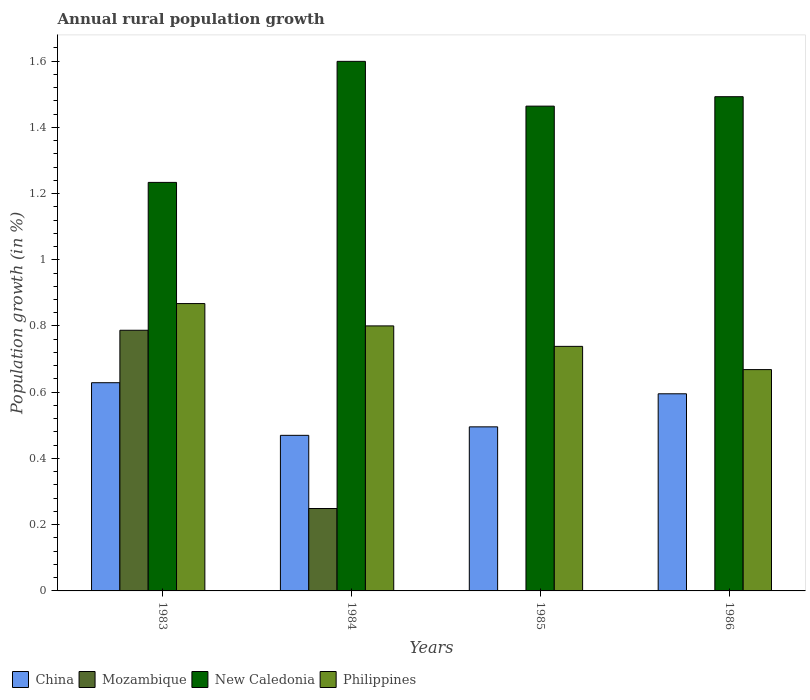How many different coloured bars are there?
Keep it short and to the point. 4. How many bars are there on the 4th tick from the right?
Ensure brevity in your answer.  4. What is the label of the 2nd group of bars from the left?
Your answer should be compact. 1984. What is the percentage of rural population growth in China in 1984?
Make the answer very short. 0.47. Across all years, what is the maximum percentage of rural population growth in China?
Offer a very short reply. 0.63. Across all years, what is the minimum percentage of rural population growth in Philippines?
Offer a terse response. 0.67. What is the total percentage of rural population growth in China in the graph?
Keep it short and to the point. 2.19. What is the difference between the percentage of rural population growth in New Caledonia in 1983 and that in 1984?
Make the answer very short. -0.37. What is the difference between the percentage of rural population growth in Philippines in 1986 and the percentage of rural population growth in China in 1985?
Ensure brevity in your answer.  0.17. What is the average percentage of rural population growth in Mozambique per year?
Make the answer very short. 0.26. In the year 1984, what is the difference between the percentage of rural population growth in China and percentage of rural population growth in Mozambique?
Your answer should be compact. 0.22. In how many years, is the percentage of rural population growth in Philippines greater than 0.9600000000000001 %?
Offer a very short reply. 0. What is the ratio of the percentage of rural population growth in Philippines in 1984 to that in 1985?
Your answer should be compact. 1.08. Is the difference between the percentage of rural population growth in China in 1983 and 1984 greater than the difference between the percentage of rural population growth in Mozambique in 1983 and 1984?
Make the answer very short. No. What is the difference between the highest and the second highest percentage of rural population growth in New Caledonia?
Offer a very short reply. 0.11. What is the difference between the highest and the lowest percentage of rural population growth in Philippines?
Your response must be concise. 0.2. Is it the case that in every year, the sum of the percentage of rural population growth in New Caledonia and percentage of rural population growth in Mozambique is greater than the percentage of rural population growth in Philippines?
Offer a very short reply. Yes. Are all the bars in the graph horizontal?
Keep it short and to the point. No. Are the values on the major ticks of Y-axis written in scientific E-notation?
Your response must be concise. No. Does the graph contain grids?
Ensure brevity in your answer.  No. How many legend labels are there?
Provide a succinct answer. 4. How are the legend labels stacked?
Your answer should be very brief. Horizontal. What is the title of the graph?
Your answer should be compact. Annual rural population growth. Does "Botswana" appear as one of the legend labels in the graph?
Offer a terse response. No. What is the label or title of the Y-axis?
Your answer should be compact. Population growth (in %). What is the Population growth (in %) in China in 1983?
Offer a terse response. 0.63. What is the Population growth (in %) of Mozambique in 1983?
Ensure brevity in your answer.  0.79. What is the Population growth (in %) in New Caledonia in 1983?
Ensure brevity in your answer.  1.23. What is the Population growth (in %) in Philippines in 1983?
Offer a very short reply. 0.87. What is the Population growth (in %) in China in 1984?
Offer a very short reply. 0.47. What is the Population growth (in %) in Mozambique in 1984?
Provide a succinct answer. 0.25. What is the Population growth (in %) of New Caledonia in 1984?
Provide a short and direct response. 1.6. What is the Population growth (in %) in Philippines in 1984?
Keep it short and to the point. 0.8. What is the Population growth (in %) in China in 1985?
Offer a terse response. 0.5. What is the Population growth (in %) of Mozambique in 1985?
Make the answer very short. 0. What is the Population growth (in %) in New Caledonia in 1985?
Keep it short and to the point. 1.46. What is the Population growth (in %) of Philippines in 1985?
Offer a very short reply. 0.74. What is the Population growth (in %) of China in 1986?
Your answer should be very brief. 0.6. What is the Population growth (in %) of Mozambique in 1986?
Your answer should be very brief. 0. What is the Population growth (in %) of New Caledonia in 1986?
Offer a terse response. 1.49. What is the Population growth (in %) of Philippines in 1986?
Your answer should be compact. 0.67. Across all years, what is the maximum Population growth (in %) of China?
Give a very brief answer. 0.63. Across all years, what is the maximum Population growth (in %) in Mozambique?
Offer a terse response. 0.79. Across all years, what is the maximum Population growth (in %) of New Caledonia?
Provide a short and direct response. 1.6. Across all years, what is the maximum Population growth (in %) of Philippines?
Offer a very short reply. 0.87. Across all years, what is the minimum Population growth (in %) in China?
Give a very brief answer. 0.47. Across all years, what is the minimum Population growth (in %) in New Caledonia?
Keep it short and to the point. 1.23. Across all years, what is the minimum Population growth (in %) of Philippines?
Offer a terse response. 0.67. What is the total Population growth (in %) of China in the graph?
Make the answer very short. 2.19. What is the total Population growth (in %) in Mozambique in the graph?
Keep it short and to the point. 1.04. What is the total Population growth (in %) in New Caledonia in the graph?
Provide a succinct answer. 5.79. What is the total Population growth (in %) in Philippines in the graph?
Give a very brief answer. 3.07. What is the difference between the Population growth (in %) of China in 1983 and that in 1984?
Provide a short and direct response. 0.16. What is the difference between the Population growth (in %) of Mozambique in 1983 and that in 1984?
Your response must be concise. 0.54. What is the difference between the Population growth (in %) of New Caledonia in 1983 and that in 1984?
Provide a short and direct response. -0.37. What is the difference between the Population growth (in %) in Philippines in 1983 and that in 1984?
Offer a terse response. 0.07. What is the difference between the Population growth (in %) of China in 1983 and that in 1985?
Provide a succinct answer. 0.13. What is the difference between the Population growth (in %) in New Caledonia in 1983 and that in 1985?
Provide a succinct answer. -0.23. What is the difference between the Population growth (in %) in Philippines in 1983 and that in 1985?
Offer a terse response. 0.13. What is the difference between the Population growth (in %) of China in 1983 and that in 1986?
Make the answer very short. 0.03. What is the difference between the Population growth (in %) of New Caledonia in 1983 and that in 1986?
Offer a terse response. -0.26. What is the difference between the Population growth (in %) of Philippines in 1983 and that in 1986?
Make the answer very short. 0.2. What is the difference between the Population growth (in %) in China in 1984 and that in 1985?
Your response must be concise. -0.03. What is the difference between the Population growth (in %) in New Caledonia in 1984 and that in 1985?
Offer a very short reply. 0.14. What is the difference between the Population growth (in %) of Philippines in 1984 and that in 1985?
Your answer should be compact. 0.06. What is the difference between the Population growth (in %) in China in 1984 and that in 1986?
Your answer should be very brief. -0.13. What is the difference between the Population growth (in %) in New Caledonia in 1984 and that in 1986?
Provide a short and direct response. 0.11. What is the difference between the Population growth (in %) in Philippines in 1984 and that in 1986?
Your answer should be compact. 0.13. What is the difference between the Population growth (in %) of China in 1985 and that in 1986?
Ensure brevity in your answer.  -0.1. What is the difference between the Population growth (in %) in New Caledonia in 1985 and that in 1986?
Your answer should be compact. -0.03. What is the difference between the Population growth (in %) in Philippines in 1985 and that in 1986?
Provide a short and direct response. 0.07. What is the difference between the Population growth (in %) of China in 1983 and the Population growth (in %) of Mozambique in 1984?
Your answer should be very brief. 0.38. What is the difference between the Population growth (in %) in China in 1983 and the Population growth (in %) in New Caledonia in 1984?
Offer a terse response. -0.97. What is the difference between the Population growth (in %) in China in 1983 and the Population growth (in %) in Philippines in 1984?
Provide a short and direct response. -0.17. What is the difference between the Population growth (in %) of Mozambique in 1983 and the Population growth (in %) of New Caledonia in 1984?
Offer a very short reply. -0.81. What is the difference between the Population growth (in %) in Mozambique in 1983 and the Population growth (in %) in Philippines in 1984?
Ensure brevity in your answer.  -0.01. What is the difference between the Population growth (in %) of New Caledonia in 1983 and the Population growth (in %) of Philippines in 1984?
Your answer should be very brief. 0.43. What is the difference between the Population growth (in %) in China in 1983 and the Population growth (in %) in New Caledonia in 1985?
Offer a terse response. -0.84. What is the difference between the Population growth (in %) of China in 1983 and the Population growth (in %) of Philippines in 1985?
Ensure brevity in your answer.  -0.11. What is the difference between the Population growth (in %) in Mozambique in 1983 and the Population growth (in %) in New Caledonia in 1985?
Keep it short and to the point. -0.68. What is the difference between the Population growth (in %) in Mozambique in 1983 and the Population growth (in %) in Philippines in 1985?
Make the answer very short. 0.05. What is the difference between the Population growth (in %) of New Caledonia in 1983 and the Population growth (in %) of Philippines in 1985?
Ensure brevity in your answer.  0.5. What is the difference between the Population growth (in %) of China in 1983 and the Population growth (in %) of New Caledonia in 1986?
Ensure brevity in your answer.  -0.86. What is the difference between the Population growth (in %) in China in 1983 and the Population growth (in %) in Philippines in 1986?
Offer a terse response. -0.04. What is the difference between the Population growth (in %) in Mozambique in 1983 and the Population growth (in %) in New Caledonia in 1986?
Offer a very short reply. -0.71. What is the difference between the Population growth (in %) of Mozambique in 1983 and the Population growth (in %) of Philippines in 1986?
Offer a very short reply. 0.12. What is the difference between the Population growth (in %) of New Caledonia in 1983 and the Population growth (in %) of Philippines in 1986?
Your answer should be very brief. 0.57. What is the difference between the Population growth (in %) in China in 1984 and the Population growth (in %) in New Caledonia in 1985?
Ensure brevity in your answer.  -0.99. What is the difference between the Population growth (in %) of China in 1984 and the Population growth (in %) of Philippines in 1985?
Keep it short and to the point. -0.27. What is the difference between the Population growth (in %) in Mozambique in 1984 and the Population growth (in %) in New Caledonia in 1985?
Offer a terse response. -1.22. What is the difference between the Population growth (in %) of Mozambique in 1984 and the Population growth (in %) of Philippines in 1985?
Your answer should be very brief. -0.49. What is the difference between the Population growth (in %) of New Caledonia in 1984 and the Population growth (in %) of Philippines in 1985?
Ensure brevity in your answer.  0.86. What is the difference between the Population growth (in %) in China in 1984 and the Population growth (in %) in New Caledonia in 1986?
Offer a very short reply. -1.02. What is the difference between the Population growth (in %) of China in 1984 and the Population growth (in %) of Philippines in 1986?
Ensure brevity in your answer.  -0.2. What is the difference between the Population growth (in %) of Mozambique in 1984 and the Population growth (in %) of New Caledonia in 1986?
Make the answer very short. -1.24. What is the difference between the Population growth (in %) in Mozambique in 1984 and the Population growth (in %) in Philippines in 1986?
Keep it short and to the point. -0.42. What is the difference between the Population growth (in %) in New Caledonia in 1984 and the Population growth (in %) in Philippines in 1986?
Your answer should be compact. 0.93. What is the difference between the Population growth (in %) in China in 1985 and the Population growth (in %) in New Caledonia in 1986?
Ensure brevity in your answer.  -1. What is the difference between the Population growth (in %) of China in 1985 and the Population growth (in %) of Philippines in 1986?
Your answer should be very brief. -0.17. What is the difference between the Population growth (in %) of New Caledonia in 1985 and the Population growth (in %) of Philippines in 1986?
Your answer should be very brief. 0.8. What is the average Population growth (in %) in China per year?
Give a very brief answer. 0.55. What is the average Population growth (in %) in Mozambique per year?
Your response must be concise. 0.26. What is the average Population growth (in %) of New Caledonia per year?
Ensure brevity in your answer.  1.45. What is the average Population growth (in %) of Philippines per year?
Offer a terse response. 0.77. In the year 1983, what is the difference between the Population growth (in %) of China and Population growth (in %) of Mozambique?
Your answer should be very brief. -0.16. In the year 1983, what is the difference between the Population growth (in %) of China and Population growth (in %) of New Caledonia?
Give a very brief answer. -0.6. In the year 1983, what is the difference between the Population growth (in %) in China and Population growth (in %) in Philippines?
Offer a terse response. -0.24. In the year 1983, what is the difference between the Population growth (in %) in Mozambique and Population growth (in %) in New Caledonia?
Ensure brevity in your answer.  -0.45. In the year 1983, what is the difference between the Population growth (in %) of Mozambique and Population growth (in %) of Philippines?
Your answer should be compact. -0.08. In the year 1983, what is the difference between the Population growth (in %) of New Caledonia and Population growth (in %) of Philippines?
Offer a terse response. 0.37. In the year 1984, what is the difference between the Population growth (in %) in China and Population growth (in %) in Mozambique?
Ensure brevity in your answer.  0.22. In the year 1984, what is the difference between the Population growth (in %) of China and Population growth (in %) of New Caledonia?
Provide a short and direct response. -1.13. In the year 1984, what is the difference between the Population growth (in %) in China and Population growth (in %) in Philippines?
Give a very brief answer. -0.33. In the year 1984, what is the difference between the Population growth (in %) in Mozambique and Population growth (in %) in New Caledonia?
Your response must be concise. -1.35. In the year 1984, what is the difference between the Population growth (in %) of Mozambique and Population growth (in %) of Philippines?
Your answer should be very brief. -0.55. In the year 1984, what is the difference between the Population growth (in %) of New Caledonia and Population growth (in %) of Philippines?
Ensure brevity in your answer.  0.8. In the year 1985, what is the difference between the Population growth (in %) of China and Population growth (in %) of New Caledonia?
Your response must be concise. -0.97. In the year 1985, what is the difference between the Population growth (in %) of China and Population growth (in %) of Philippines?
Give a very brief answer. -0.24. In the year 1985, what is the difference between the Population growth (in %) of New Caledonia and Population growth (in %) of Philippines?
Ensure brevity in your answer.  0.73. In the year 1986, what is the difference between the Population growth (in %) of China and Population growth (in %) of New Caledonia?
Your answer should be compact. -0.9. In the year 1986, what is the difference between the Population growth (in %) in China and Population growth (in %) in Philippines?
Keep it short and to the point. -0.07. In the year 1986, what is the difference between the Population growth (in %) of New Caledonia and Population growth (in %) of Philippines?
Your answer should be compact. 0.82. What is the ratio of the Population growth (in %) in China in 1983 to that in 1984?
Offer a terse response. 1.34. What is the ratio of the Population growth (in %) of Mozambique in 1983 to that in 1984?
Your answer should be very brief. 3.16. What is the ratio of the Population growth (in %) of New Caledonia in 1983 to that in 1984?
Offer a terse response. 0.77. What is the ratio of the Population growth (in %) of Philippines in 1983 to that in 1984?
Make the answer very short. 1.08. What is the ratio of the Population growth (in %) of China in 1983 to that in 1985?
Offer a very short reply. 1.27. What is the ratio of the Population growth (in %) in New Caledonia in 1983 to that in 1985?
Offer a terse response. 0.84. What is the ratio of the Population growth (in %) of Philippines in 1983 to that in 1985?
Provide a short and direct response. 1.18. What is the ratio of the Population growth (in %) in China in 1983 to that in 1986?
Offer a very short reply. 1.06. What is the ratio of the Population growth (in %) of New Caledonia in 1983 to that in 1986?
Offer a terse response. 0.83. What is the ratio of the Population growth (in %) of Philippines in 1983 to that in 1986?
Your answer should be very brief. 1.3. What is the ratio of the Population growth (in %) of China in 1984 to that in 1985?
Provide a short and direct response. 0.95. What is the ratio of the Population growth (in %) in New Caledonia in 1984 to that in 1985?
Offer a very short reply. 1.09. What is the ratio of the Population growth (in %) of Philippines in 1984 to that in 1985?
Your answer should be very brief. 1.08. What is the ratio of the Population growth (in %) of China in 1984 to that in 1986?
Give a very brief answer. 0.79. What is the ratio of the Population growth (in %) in New Caledonia in 1984 to that in 1986?
Your response must be concise. 1.07. What is the ratio of the Population growth (in %) in Philippines in 1984 to that in 1986?
Your response must be concise. 1.2. What is the ratio of the Population growth (in %) in China in 1985 to that in 1986?
Your answer should be very brief. 0.83. What is the ratio of the Population growth (in %) of New Caledonia in 1985 to that in 1986?
Your answer should be compact. 0.98. What is the ratio of the Population growth (in %) in Philippines in 1985 to that in 1986?
Your answer should be compact. 1.1. What is the difference between the highest and the second highest Population growth (in %) of China?
Provide a short and direct response. 0.03. What is the difference between the highest and the second highest Population growth (in %) of New Caledonia?
Keep it short and to the point. 0.11. What is the difference between the highest and the second highest Population growth (in %) of Philippines?
Make the answer very short. 0.07. What is the difference between the highest and the lowest Population growth (in %) of China?
Your response must be concise. 0.16. What is the difference between the highest and the lowest Population growth (in %) of Mozambique?
Offer a very short reply. 0.79. What is the difference between the highest and the lowest Population growth (in %) of New Caledonia?
Your response must be concise. 0.37. What is the difference between the highest and the lowest Population growth (in %) of Philippines?
Ensure brevity in your answer.  0.2. 